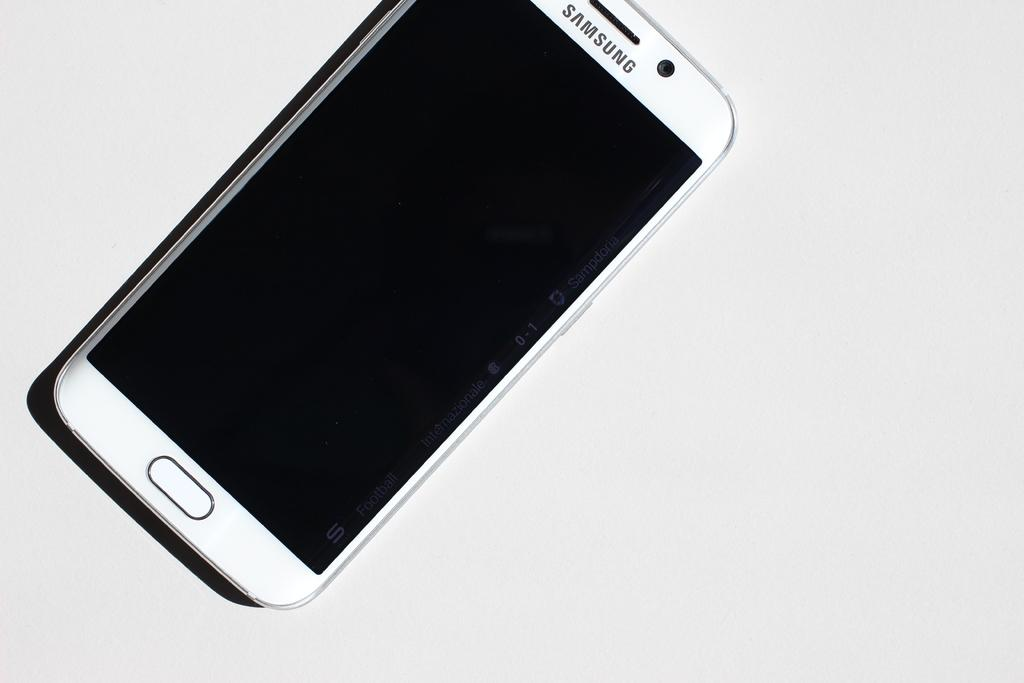Provide a one-sentence caption for the provided image. A Samsung phone with a black screen sits on a white background. 